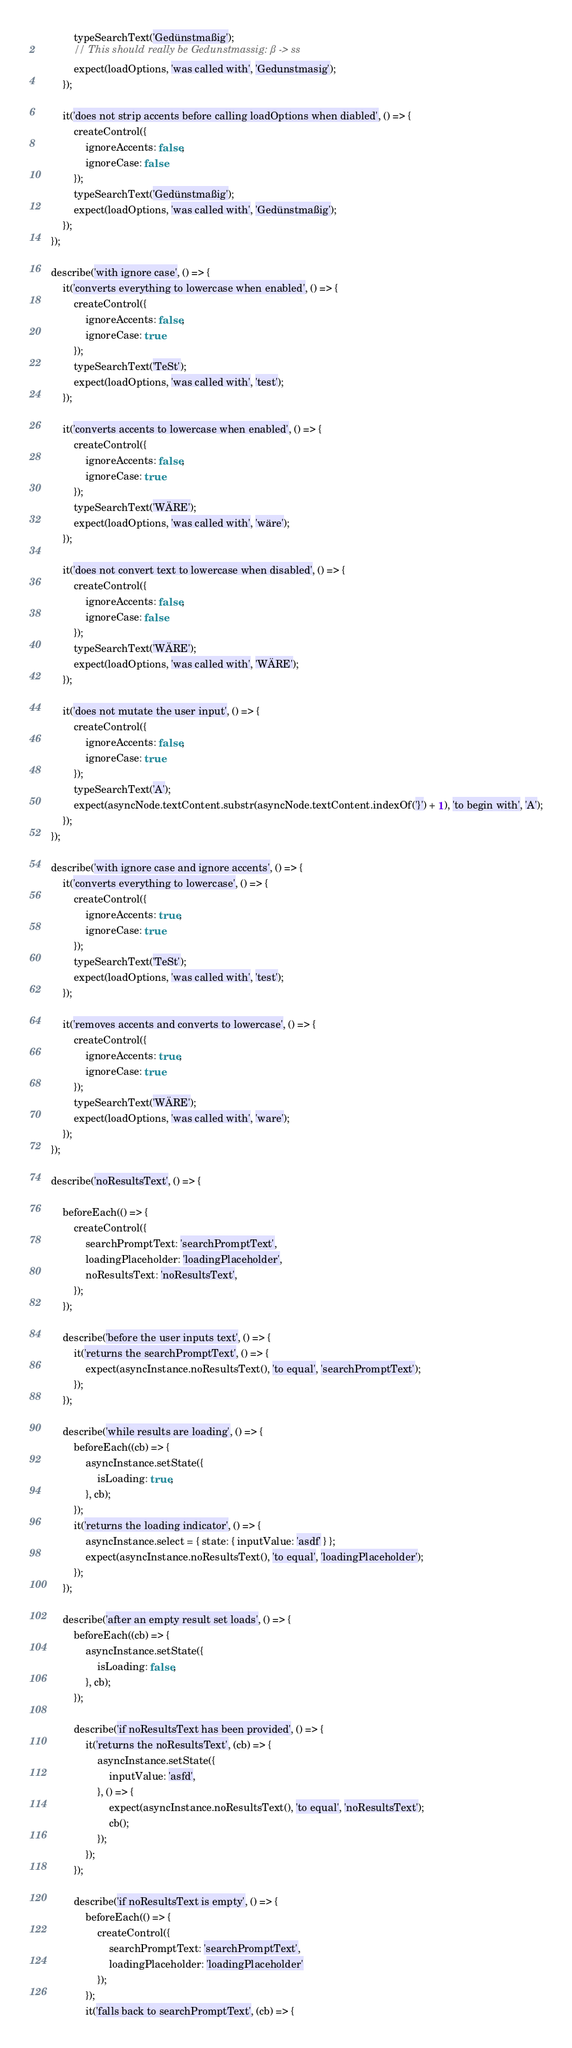<code> <loc_0><loc_0><loc_500><loc_500><_JavaScript_>			typeSearchText('Gedünstmaßig');
			// This should really be Gedunstmassig: ß -> ss
			expect(loadOptions, 'was called with', 'Gedunstmasig');
		});

		it('does not strip accents before calling loadOptions when diabled', () => {
			createControl({
				ignoreAccents: false,
				ignoreCase: false
			});
			typeSearchText('Gedünstmaßig');
			expect(loadOptions, 'was called with', 'Gedünstmaßig');
		});
	});

	describe('with ignore case', () => {
		it('converts everything to lowercase when enabled', () => {
			createControl({
				ignoreAccents: false,
				ignoreCase: true
			});
			typeSearchText('TeSt');
			expect(loadOptions, 'was called with', 'test');
		});

		it('converts accents to lowercase when enabled', () => {
			createControl({
				ignoreAccents: false,
				ignoreCase: true
			});
			typeSearchText('WÄRE');
			expect(loadOptions, 'was called with', 'wäre');
		});

		it('does not convert text to lowercase when disabled', () => {
			createControl({
				ignoreAccents: false,
				ignoreCase: false
			});
			typeSearchText('WÄRE');
			expect(loadOptions, 'was called with', 'WÄRE');
		});

		it('does not mutate the user input', () => {
			createControl({
				ignoreAccents: false,
				ignoreCase: true
			});
			typeSearchText('A');
			expect(asyncNode.textContent.substr(asyncNode.textContent.indexOf('}') + 1), 'to begin with', 'A');
		});
	});

	describe('with ignore case and ignore accents', () => {
		it('converts everything to lowercase', () => {
			createControl({
				ignoreAccents: true,
				ignoreCase: true
			});
			typeSearchText('TeSt');
			expect(loadOptions, 'was called with', 'test');
		});

		it('removes accents and converts to lowercase', () => {
			createControl({
				ignoreAccents: true,
				ignoreCase: true
			});
			typeSearchText('WÄRE');
			expect(loadOptions, 'was called with', 'ware');
		});
	});

	describe('noResultsText', () => {

		beforeEach(() => {
			createControl({
				searchPromptText: 'searchPromptText',
				loadingPlaceholder: 'loadingPlaceholder',
				noResultsText: 'noResultsText',
			});
		});

		describe('before the user inputs text', () => {
			it('returns the searchPromptText', () => {
				expect(asyncInstance.noResultsText(), 'to equal', 'searchPromptText');
			});
		});

		describe('while results are loading', () => {
			beforeEach((cb) => {
				asyncInstance.setState({
					isLoading: true,
				}, cb);
			});
			it('returns the loading indicator', () => {
				asyncInstance.select = { state: { inputValue: 'asdf' } };
				expect(asyncInstance.noResultsText(), 'to equal', 'loadingPlaceholder');
			});
		});

		describe('after an empty result set loads', () => {
			beforeEach((cb) => {
				asyncInstance.setState({
					isLoading: false,
				}, cb);
			});

			describe('if noResultsText has been provided', () => {
				it('returns the noResultsText', (cb) => {
					asyncInstance.setState({
						inputValue: 'asfd',
					}, () => {
						expect(asyncInstance.noResultsText(), 'to equal', 'noResultsText');
						cb();
					});
				});
			});

			describe('if noResultsText is empty', () => {
				beforeEach(() => {
					createControl({
						searchPromptText: 'searchPromptText',
						loadingPlaceholder: 'loadingPlaceholder'
					});
				});
				it('falls back to searchPromptText', (cb) => {</code> 